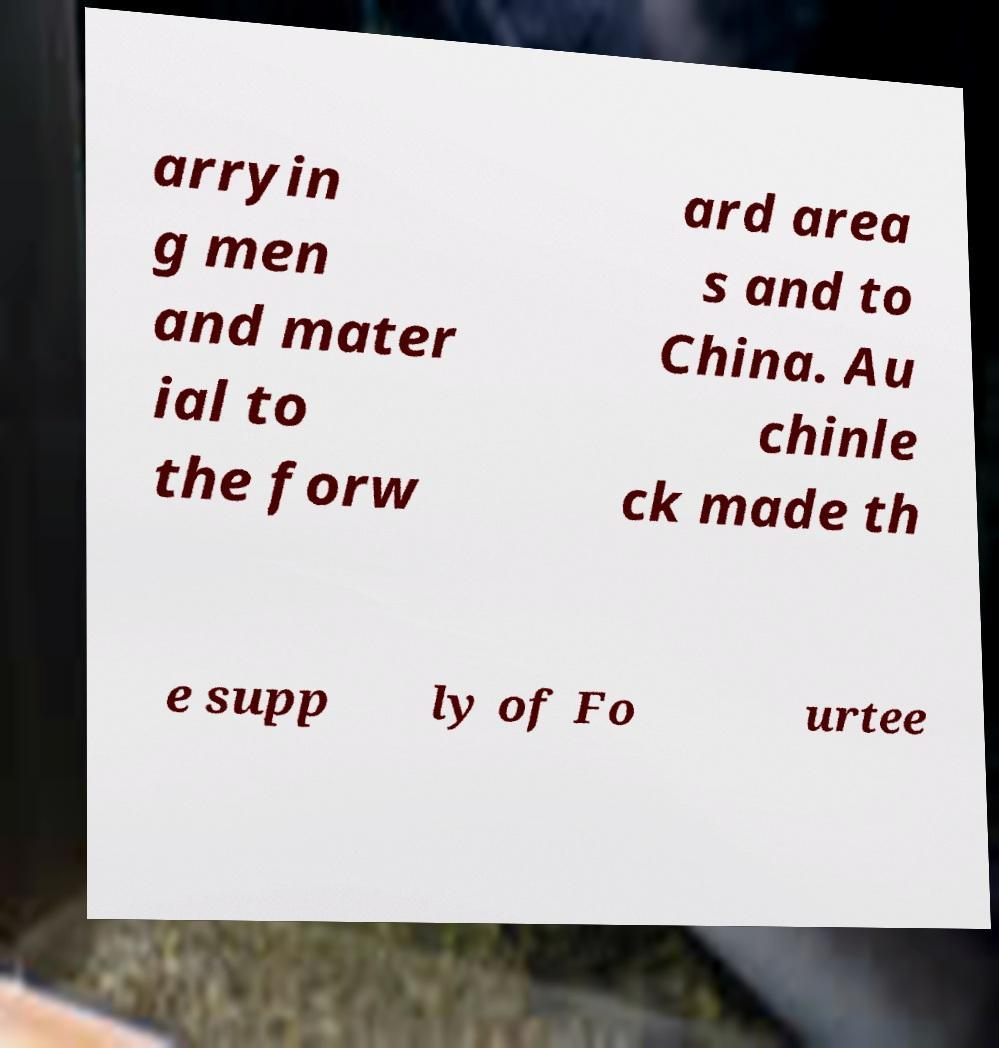What messages or text are displayed in this image? I need them in a readable, typed format. arryin g men and mater ial to the forw ard area s and to China. Au chinle ck made th e supp ly of Fo urtee 